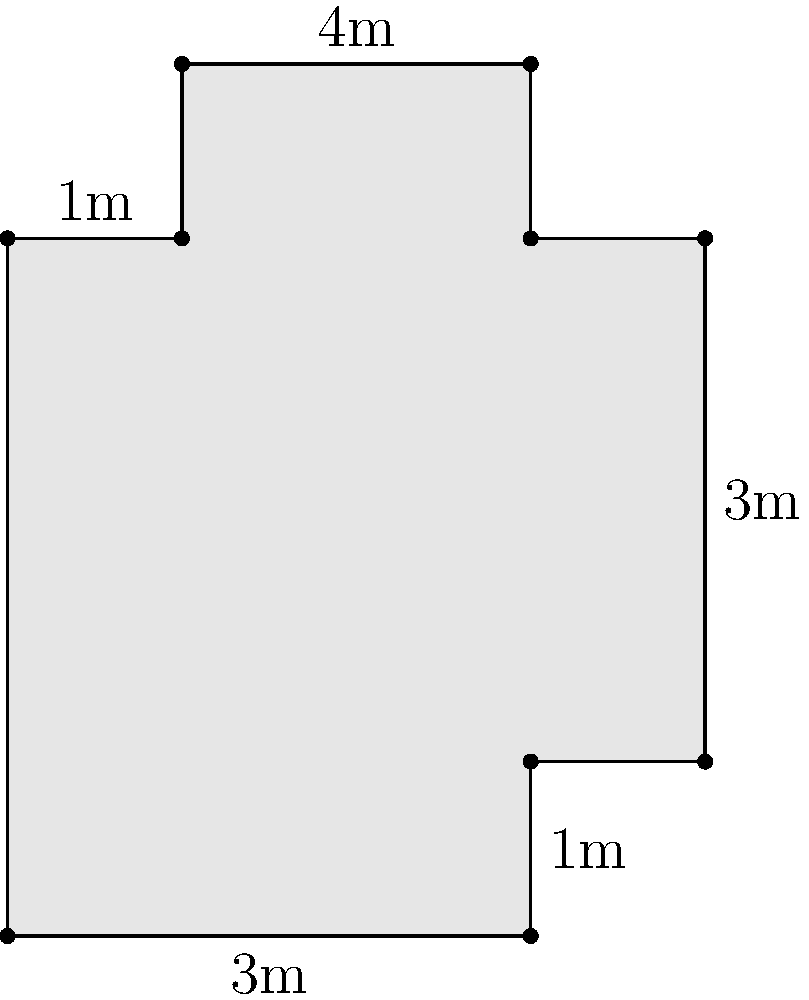As a medieval reenactor specializing in the period of the Counts of Flanders, you've been tasked with calculating the floor area of a newly discovered cross-shaped Flemish cathedral from the 12th century. The floor plan is shown in the diagram above, with measurements in meters. What is the total area of the cathedral's floor in square meters? To calculate the area of this cross-shaped floor plan, we can break it down into rectangles:

1. Main rectangle:
   Length = 4m, Width = 3m
   Area = 4m × 3m = 12m²

2. Top extension:
   Length = 2m, Width = 1m
   Area = 2m × 1m = 2m²

3. Bottom extension:
   Length = 3m, Width = 1m
   Area = 3m × 1m = 3m²

Now, we sum up all the areas:
Total Area = Main rectangle + Top extension + Bottom extension
           = 12m² + 2m² + 3m²
           = 17m²

Therefore, the total floor area of the Flemish cathedral is 17 square meters.
Answer: 17m² 